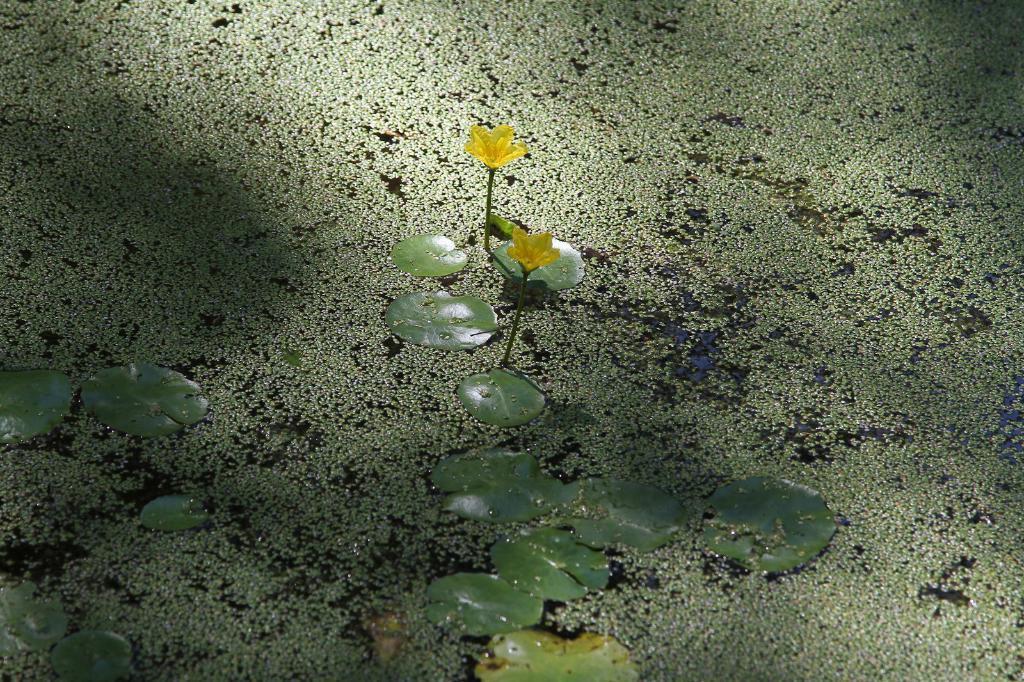Please provide a concise description of this image. In this image there are leaves. 